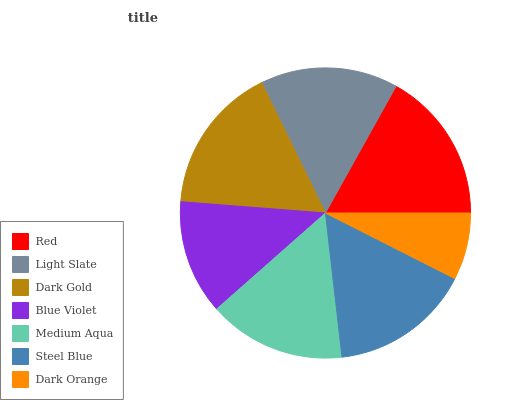Is Dark Orange the minimum?
Answer yes or no. Yes. Is Red the maximum?
Answer yes or no. Yes. Is Light Slate the minimum?
Answer yes or no. No. Is Light Slate the maximum?
Answer yes or no. No. Is Red greater than Light Slate?
Answer yes or no. Yes. Is Light Slate less than Red?
Answer yes or no. Yes. Is Light Slate greater than Red?
Answer yes or no. No. Is Red less than Light Slate?
Answer yes or no. No. Is Light Slate the high median?
Answer yes or no. Yes. Is Light Slate the low median?
Answer yes or no. Yes. Is Steel Blue the high median?
Answer yes or no. No. Is Red the low median?
Answer yes or no. No. 